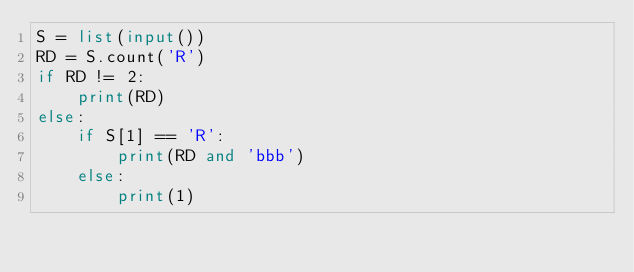Convert code to text. <code><loc_0><loc_0><loc_500><loc_500><_Python_>S = list(input())
RD = S.count('R')
if RD != 2:
    print(RD)
else:
    if S[1] == 'R':
        print(RD and 'bbb')
    else:
        print(1)
</code> 